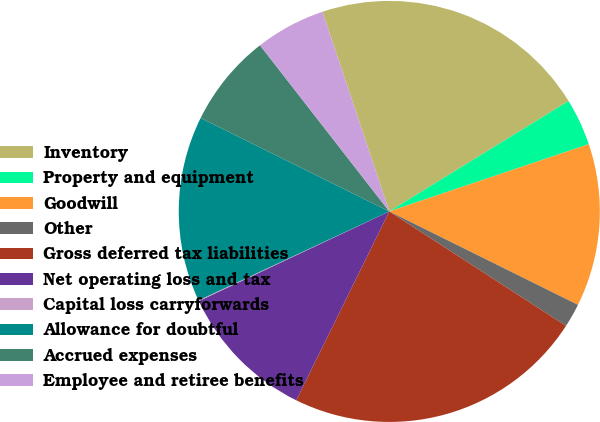Convert chart. <chart><loc_0><loc_0><loc_500><loc_500><pie_chart><fcel>Inventory<fcel>Property and equipment<fcel>Goodwill<fcel>Other<fcel>Gross deferred tax liabilities<fcel>Net operating loss and tax<fcel>Capital loss carryforwards<fcel>Allowance for doubtful<fcel>Accrued expenses<fcel>Employee and retiree benefits<nl><fcel>21.36%<fcel>3.61%<fcel>12.49%<fcel>1.83%<fcel>23.14%<fcel>10.71%<fcel>0.06%<fcel>14.26%<fcel>7.16%<fcel>5.38%<nl></chart> 